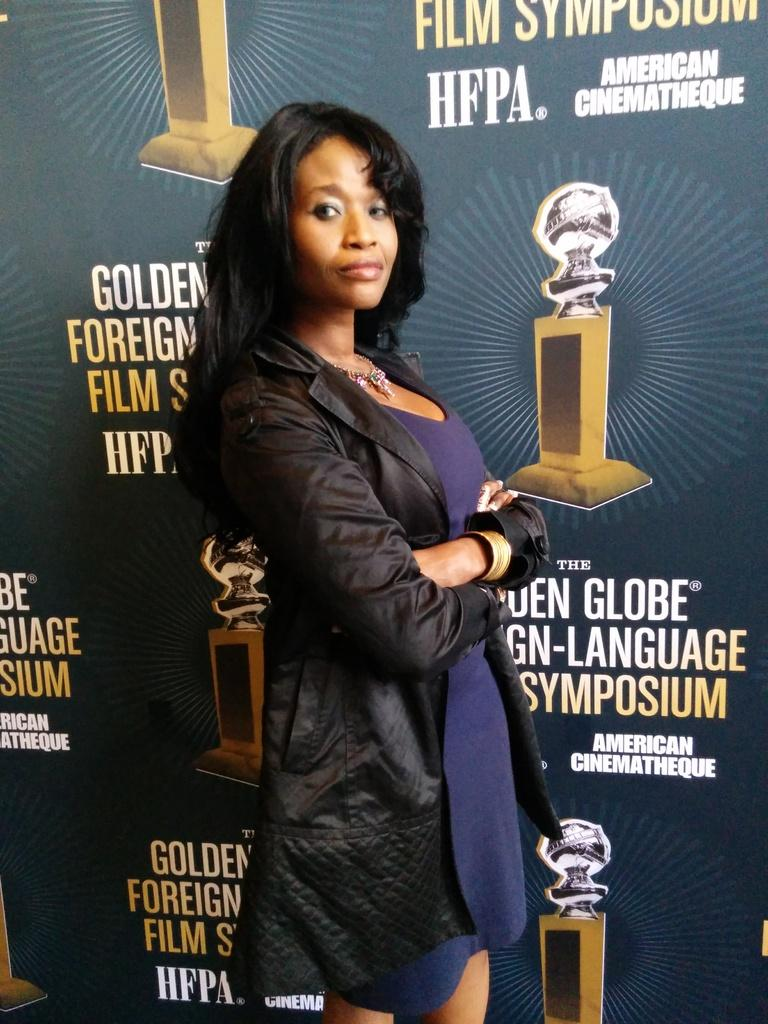What is the main subject of the image? There is a woman standing in the center of the image. Can you describe the background of the image? There is a poster in the background of the image. What type of apparel is the porter wearing in the image? There is no porter present in the image, and therefore no apparel can be attributed to a porter. 